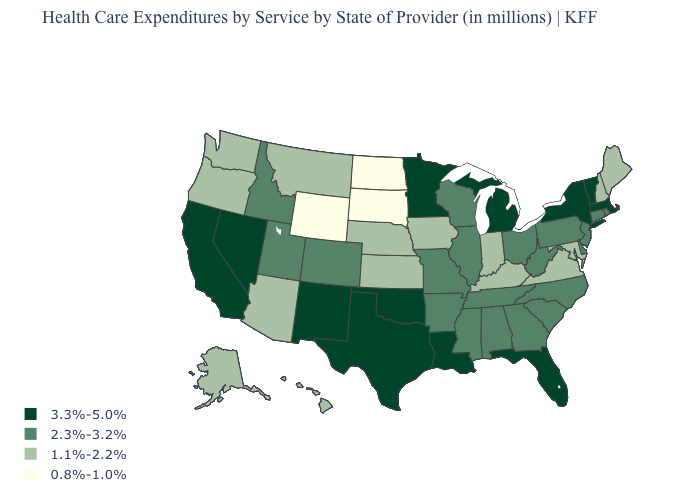What is the lowest value in the USA?
Keep it brief. 0.8%-1.0%. Does Illinois have the lowest value in the MidWest?
Short answer required. No. Name the states that have a value in the range 0.8%-1.0%?
Concise answer only. North Dakota, South Dakota, Wyoming. Does Vermont have a lower value than Florida?
Keep it brief. No. Does Wisconsin have a higher value than Arkansas?
Give a very brief answer. No. What is the highest value in the USA?
Keep it brief. 3.3%-5.0%. What is the highest value in states that border Idaho?
Be succinct. 3.3%-5.0%. Does New York have the highest value in the USA?
Be succinct. Yes. How many symbols are there in the legend?
Keep it brief. 4. Does the map have missing data?
Keep it brief. No. Which states have the highest value in the USA?
Give a very brief answer. California, Florida, Louisiana, Massachusetts, Michigan, Minnesota, Nevada, New Mexico, New York, Oklahoma, Texas, Vermont. Among the states that border New Hampshire , which have the highest value?
Write a very short answer. Massachusetts, Vermont. Name the states that have a value in the range 0.8%-1.0%?
Write a very short answer. North Dakota, South Dakota, Wyoming. How many symbols are there in the legend?
Concise answer only. 4. Name the states that have a value in the range 2.3%-3.2%?
Answer briefly. Alabama, Arkansas, Colorado, Connecticut, Delaware, Georgia, Idaho, Illinois, Mississippi, Missouri, New Jersey, North Carolina, Ohio, Pennsylvania, Rhode Island, South Carolina, Tennessee, Utah, West Virginia, Wisconsin. 